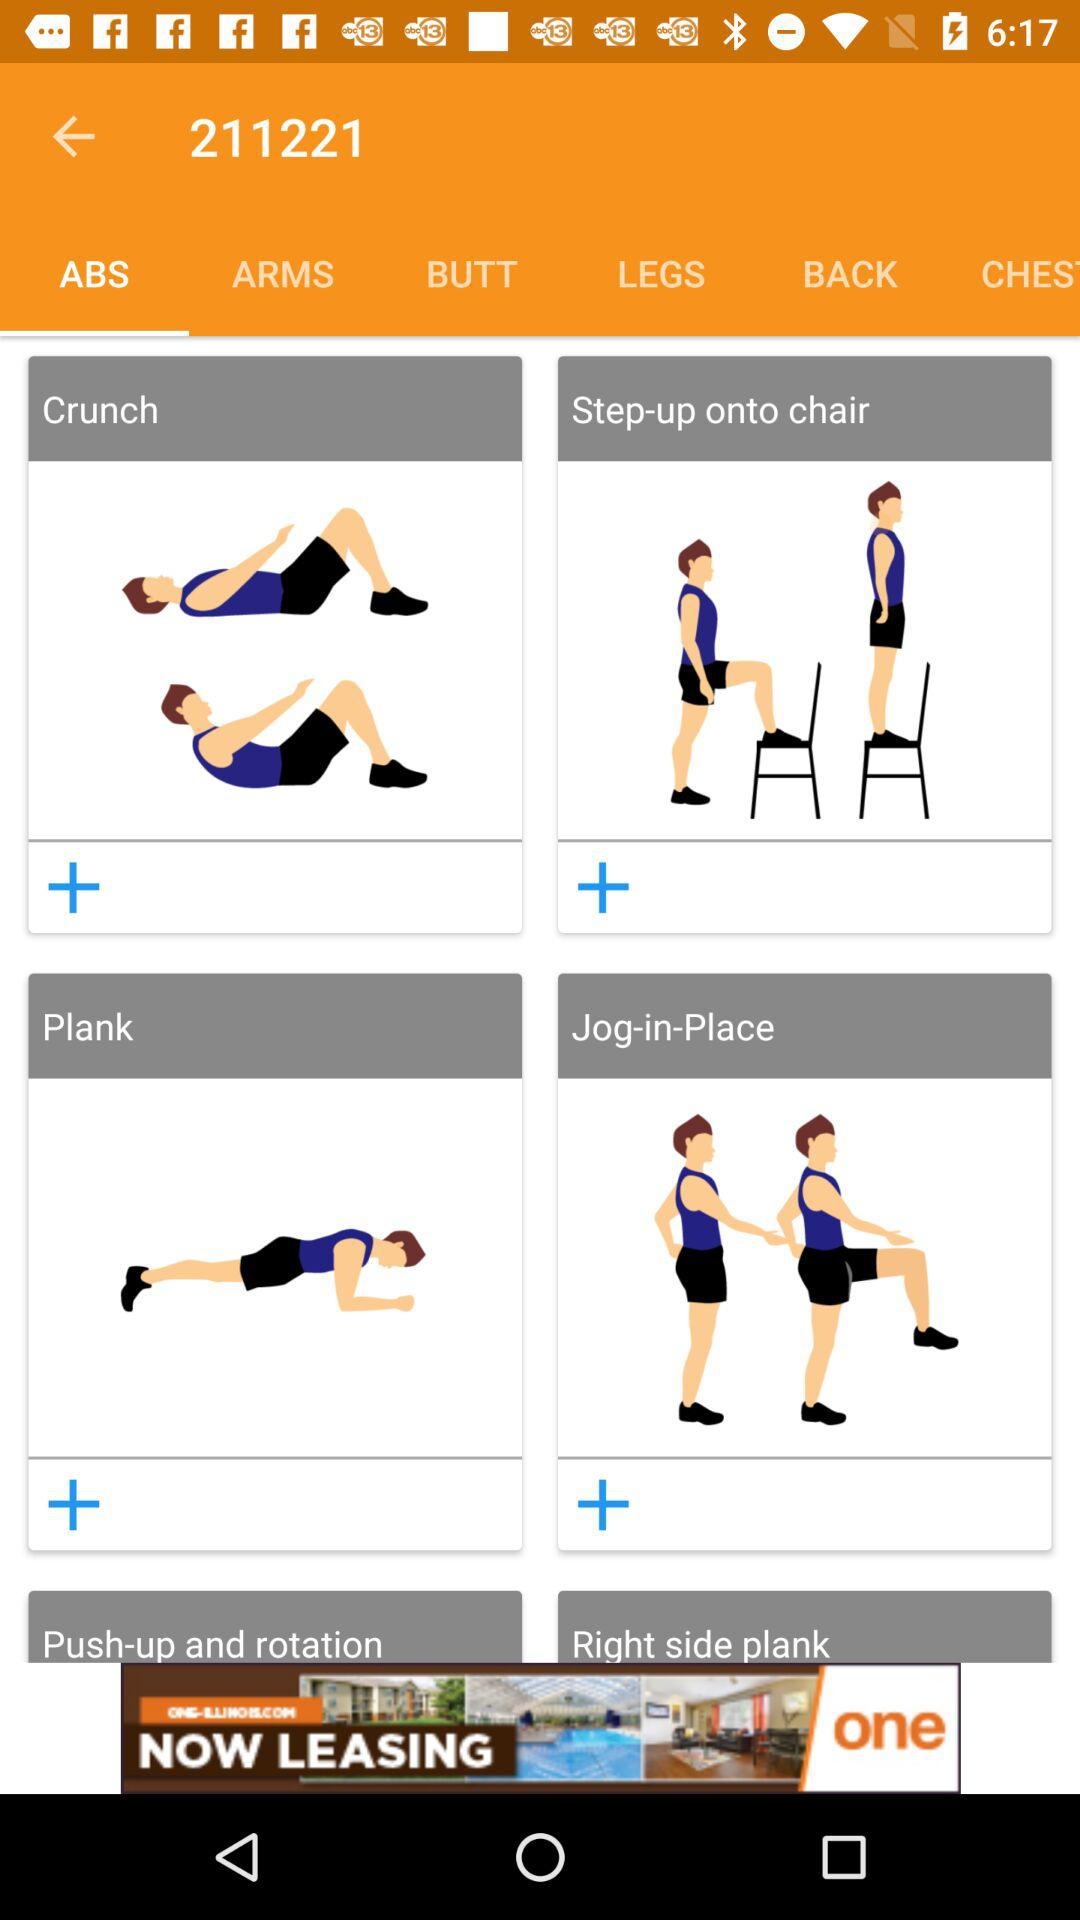How many exercises are there in total?
Answer the question using a single word or phrase. 6 